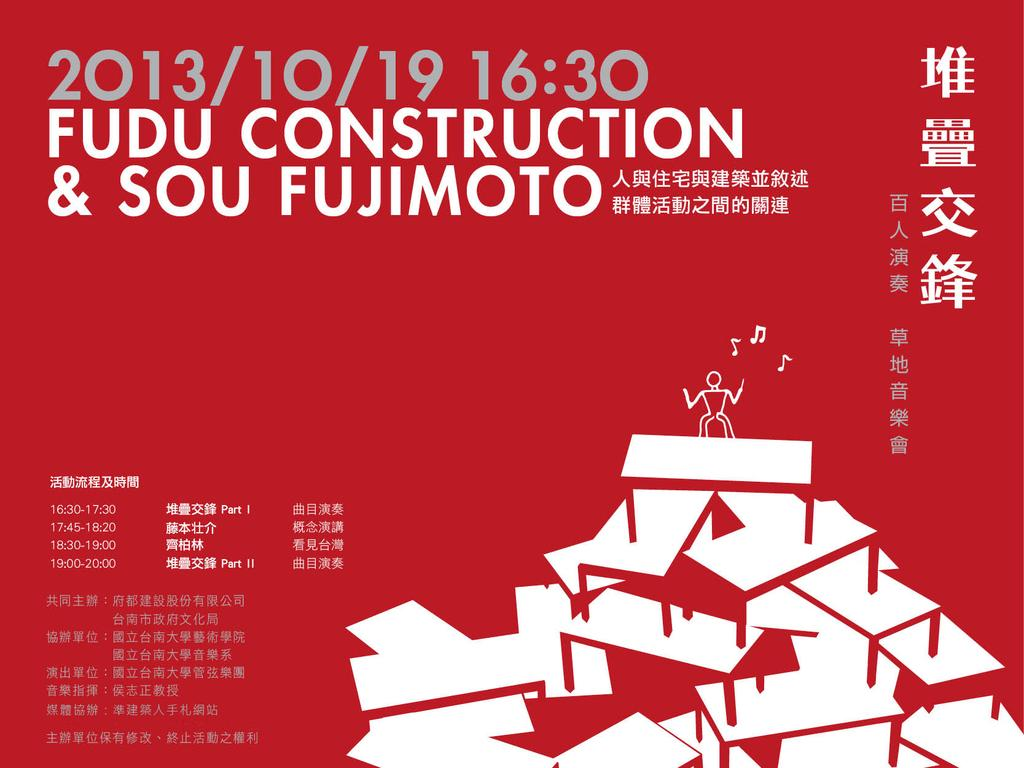<image>
Summarize the visual content of the image. A red banner with Asian writing and Fudu Construction on it. 